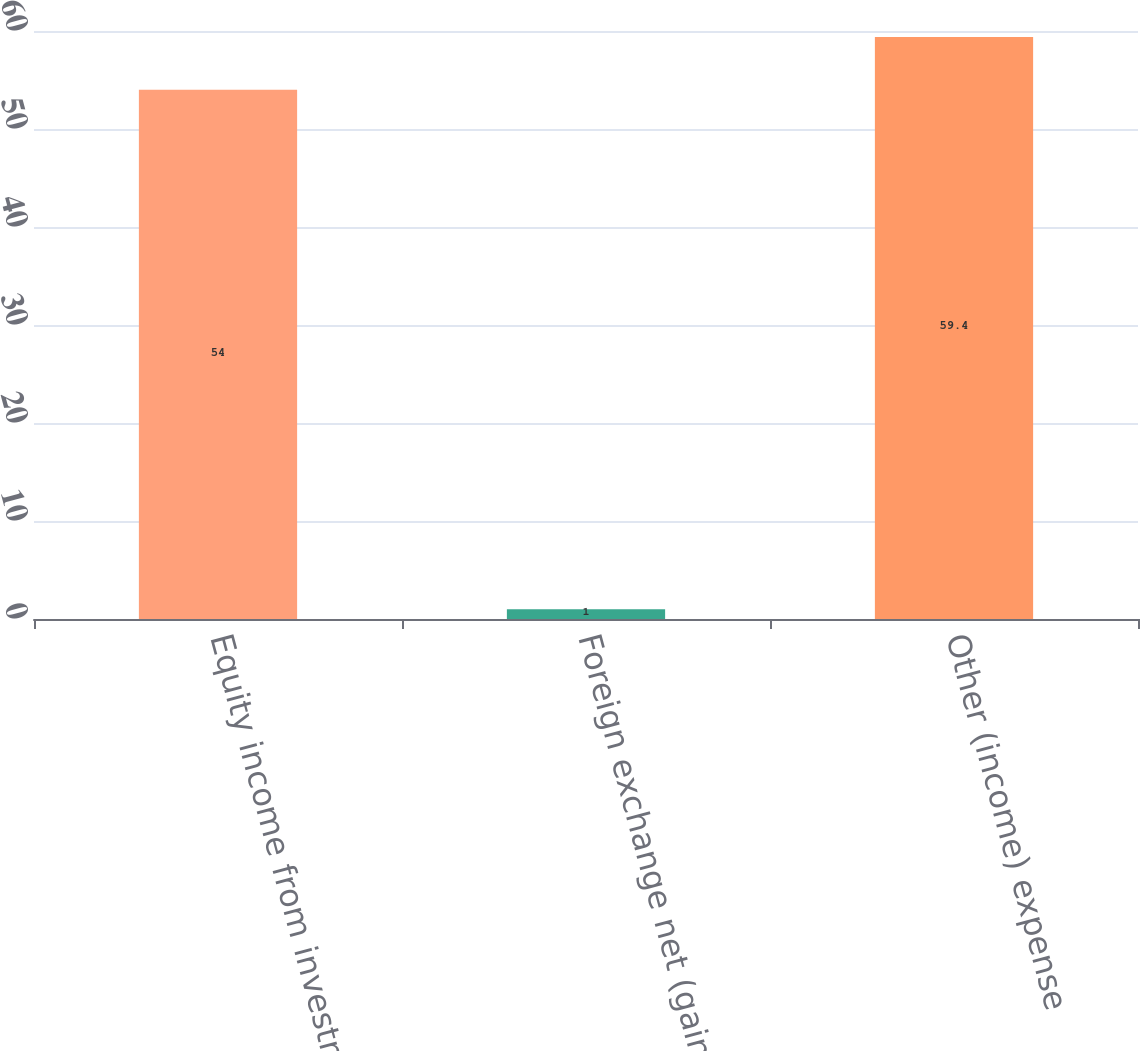Convert chart to OTSL. <chart><loc_0><loc_0><loc_500><loc_500><bar_chart><fcel>Equity income from investments<fcel>Foreign exchange net (gain)<fcel>Other (income) expense<nl><fcel>54<fcel>1<fcel>59.4<nl></chart> 